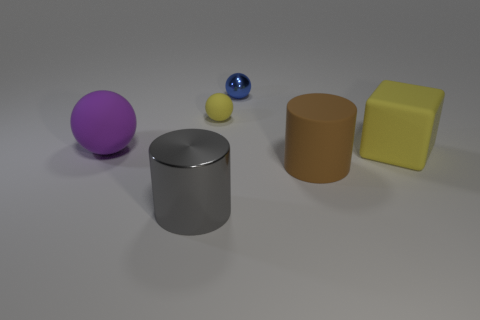Subtract all rubber spheres. How many spheres are left? 1 Add 4 big purple rubber things. How many objects exist? 10 Subtract all cubes. How many objects are left? 5 Subtract 0 red spheres. How many objects are left? 6 Subtract all tiny blue metallic spheres. Subtract all small metallic objects. How many objects are left? 4 Add 6 gray shiny things. How many gray shiny things are left? 7 Add 5 brown blocks. How many brown blocks exist? 5 